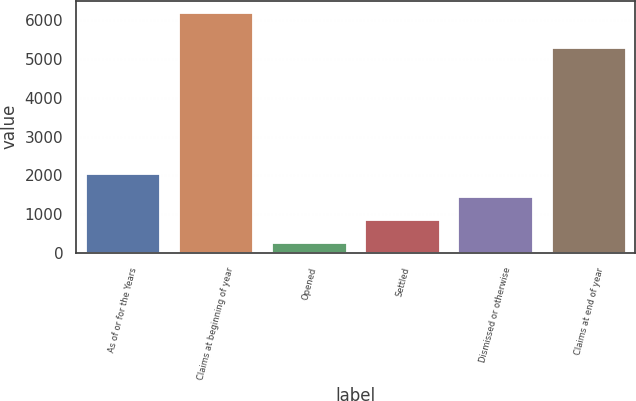Convert chart to OTSL. <chart><loc_0><loc_0><loc_500><loc_500><bar_chart><fcel>As of or for the Years<fcel>Claims at beginning of year<fcel>Opened<fcel>Settled<fcel>Dismissed or otherwise<fcel>Claims at end of year<nl><fcel>2038.3<fcel>6197<fcel>256<fcel>850.1<fcel>1444.2<fcel>5289<nl></chart> 